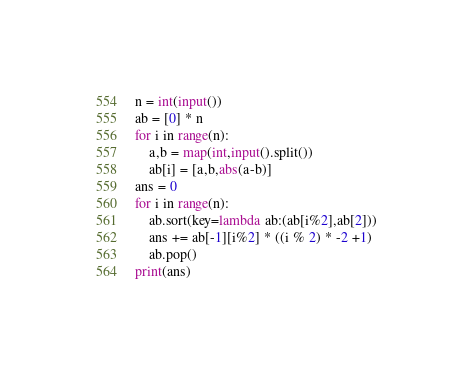Convert code to text. <code><loc_0><loc_0><loc_500><loc_500><_Python_>n = int(input())
ab = [0] * n
for i in range(n):
    a,b = map(int,input().split())
    ab[i] = [a,b,abs(a-b)]
ans = 0
for i in range(n):
    ab.sort(key=lambda ab:(ab[i%2],ab[2]))
    ans += ab[-1][i%2] * ((i % 2) * -2 +1)
    ab.pop()
print(ans)</code> 